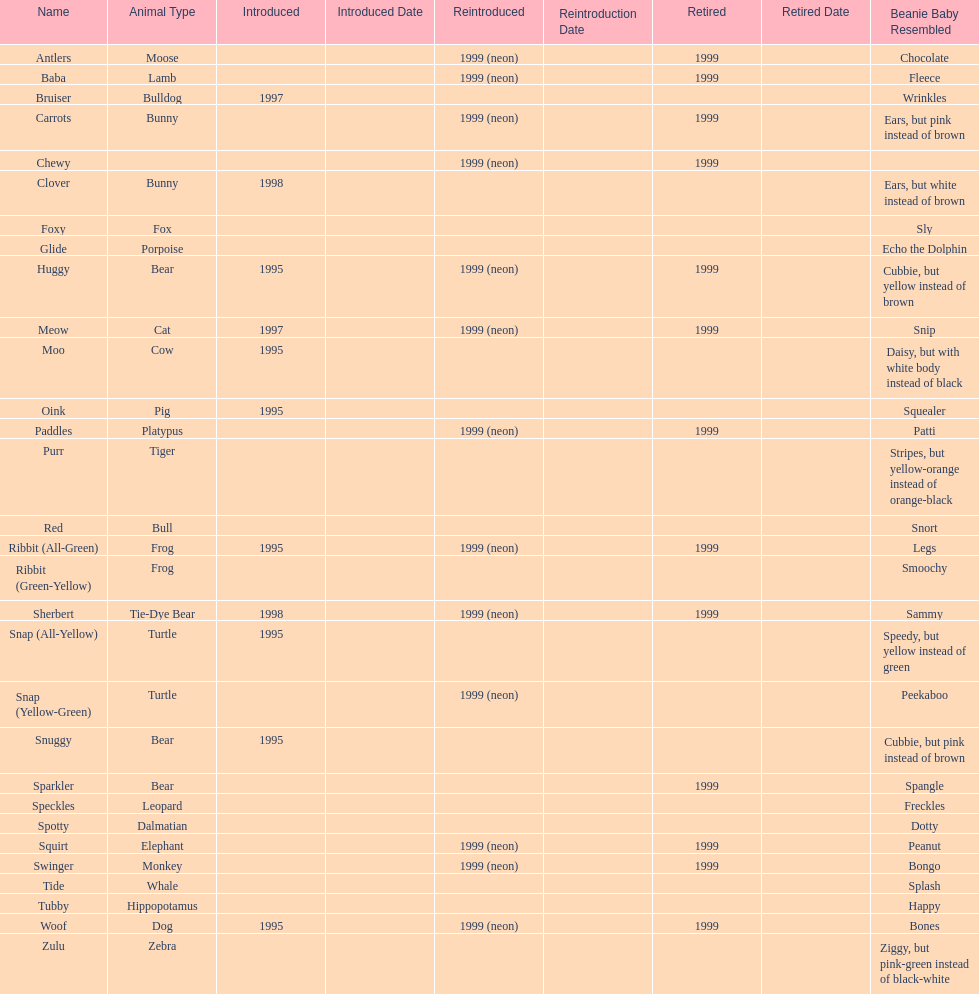How many total pillow pals were both reintroduced and retired in 1999? 12. 